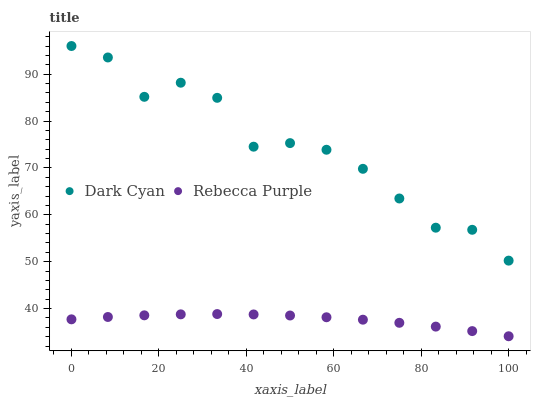Does Rebecca Purple have the minimum area under the curve?
Answer yes or no. Yes. Does Dark Cyan have the maximum area under the curve?
Answer yes or no. Yes. Does Rebecca Purple have the maximum area under the curve?
Answer yes or no. No. Is Rebecca Purple the smoothest?
Answer yes or no. Yes. Is Dark Cyan the roughest?
Answer yes or no. Yes. Is Rebecca Purple the roughest?
Answer yes or no. No. Does Rebecca Purple have the lowest value?
Answer yes or no. Yes. Does Dark Cyan have the highest value?
Answer yes or no. Yes. Does Rebecca Purple have the highest value?
Answer yes or no. No. Is Rebecca Purple less than Dark Cyan?
Answer yes or no. Yes. Is Dark Cyan greater than Rebecca Purple?
Answer yes or no. Yes. Does Rebecca Purple intersect Dark Cyan?
Answer yes or no. No. 